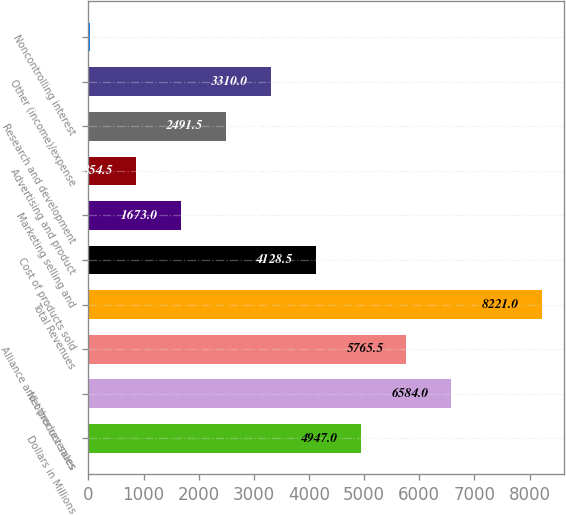Convert chart. <chart><loc_0><loc_0><loc_500><loc_500><bar_chart><fcel>Dollars in Millions<fcel>Net product sales<fcel>Alliance and other revenues<fcel>Total Revenues<fcel>Cost of products sold<fcel>Marketing selling and<fcel>Advertising and product<fcel>Research and development<fcel>Other (income)/expense<fcel>Noncontrolling interest<nl><fcel>4947<fcel>6584<fcel>5765.5<fcel>8221<fcel>4128.5<fcel>1673<fcel>854.5<fcel>2491.5<fcel>3310<fcel>36<nl></chart> 